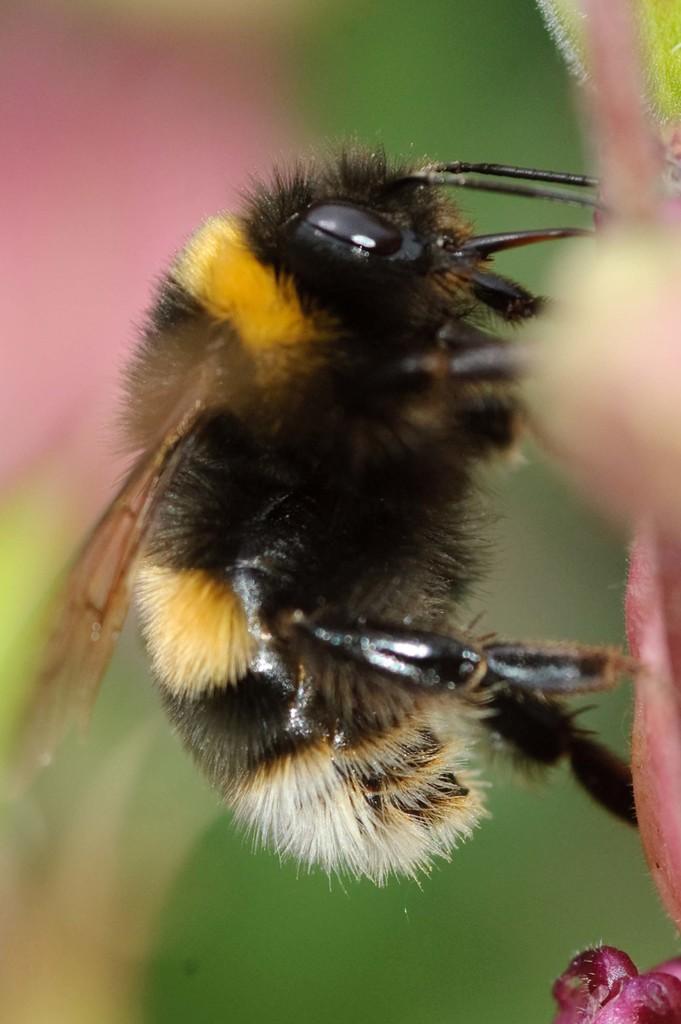Please provide a concise description of this image. Background portion of the picture is blur. In this picture we can see an insect and on the left side of the picture its blurry. 